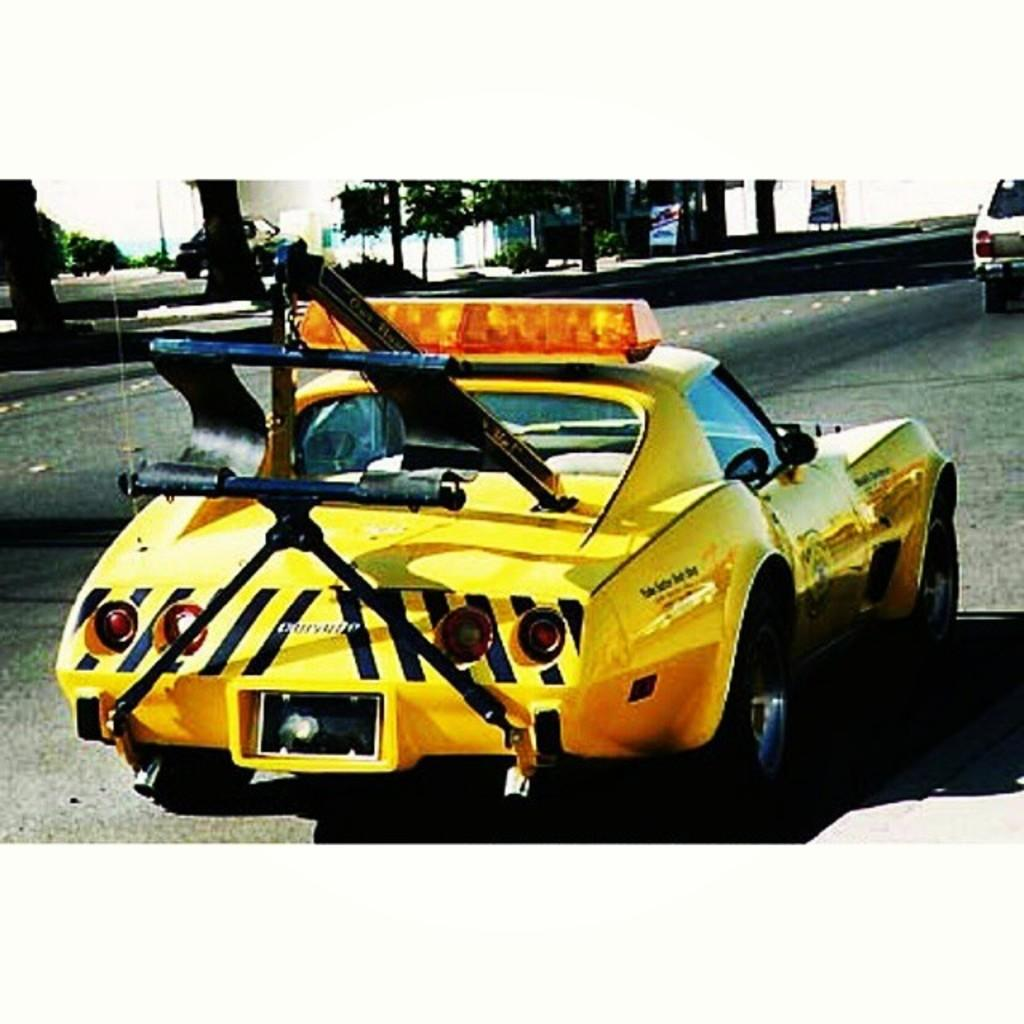What colors are the cars in the image? There is a yellow color car and a white color car in the image. Where are the cars located in the image? Both cars are on the road in the image. What can be seen in the background of the image? There are trees, plants, hoardings, and the sky visible in the background of the image. Can you see any geese walking on the roof in the image? There are no geese or roof present in the image; it features two cars on the road and a background with trees, plants, hoardings, and the sky. 